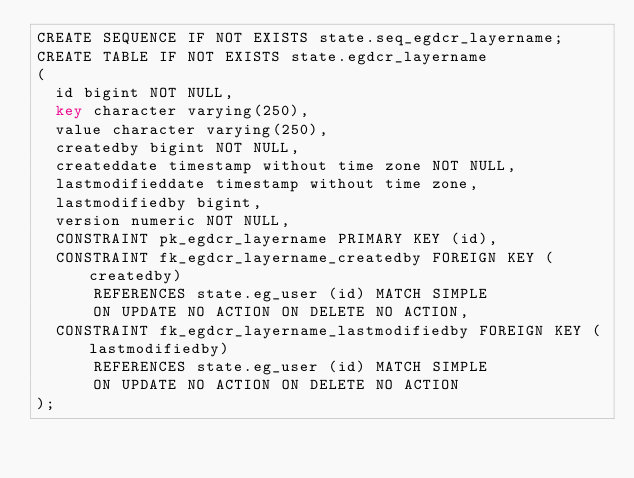Convert code to text. <code><loc_0><loc_0><loc_500><loc_500><_SQL_>CREATE SEQUENCE IF NOT EXISTS state.seq_egdcr_layername;
CREATE TABLE IF NOT EXISTS state.egdcr_layername
(
  id bigint NOT NULL,
  key character varying(250),
  value character varying(250),
  createdby bigint NOT NULL,
  createddate timestamp without time zone NOT NULL,
  lastmodifieddate timestamp without time zone,
  lastmodifiedby bigint,
  version numeric NOT NULL,
  CONSTRAINT pk_egdcr_layername PRIMARY KEY (id),
  CONSTRAINT fk_egdcr_layername_createdby FOREIGN KEY (createdby)
      REFERENCES state.eg_user (id) MATCH SIMPLE
      ON UPDATE NO ACTION ON DELETE NO ACTION,
  CONSTRAINT fk_egdcr_layername_lastmodifiedby FOREIGN KEY (lastmodifiedby)
      REFERENCES state.eg_user (id) MATCH SIMPLE
      ON UPDATE NO ACTION ON DELETE NO ACTION
);</code> 